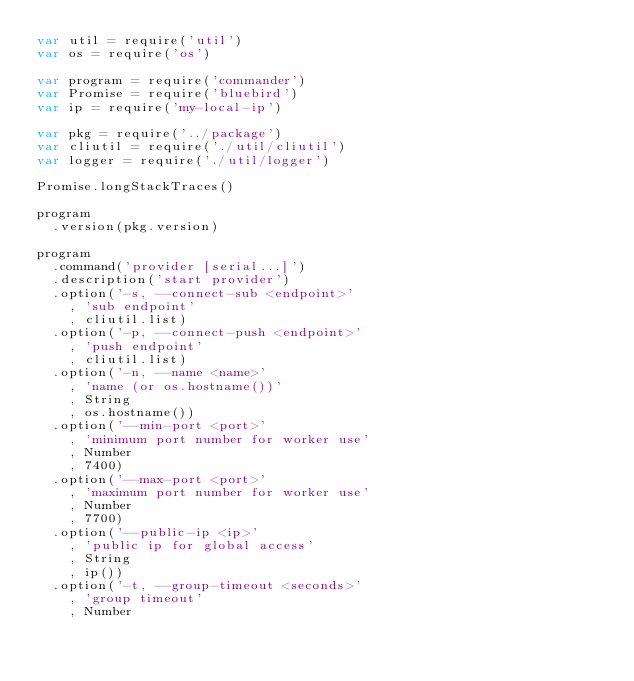Convert code to text. <code><loc_0><loc_0><loc_500><loc_500><_JavaScript_>var util = require('util')
var os = require('os')

var program = require('commander')
var Promise = require('bluebird')
var ip = require('my-local-ip')

var pkg = require('../package')
var cliutil = require('./util/cliutil')
var logger = require('./util/logger')

Promise.longStackTraces()

program
  .version(pkg.version)

program
  .command('provider [serial...]')
  .description('start provider')
  .option('-s, --connect-sub <endpoint>'
    , 'sub endpoint'
    , cliutil.list)
  .option('-p, --connect-push <endpoint>'
    , 'push endpoint'
    , cliutil.list)
  .option('-n, --name <name>'
    , 'name (or os.hostname())'
    , String
    , os.hostname())
  .option('--min-port <port>'
    , 'minimum port number for worker use'
    , Number
    , 7400)
  .option('--max-port <port>'
    , 'maximum port number for worker use'
    , Number
    , 7700)
  .option('--public-ip <ip>'
    , 'public ip for global access'
    , String
    , ip())
  .option('-t, --group-timeout <seconds>'
    , 'group timeout'
    , Number</code> 